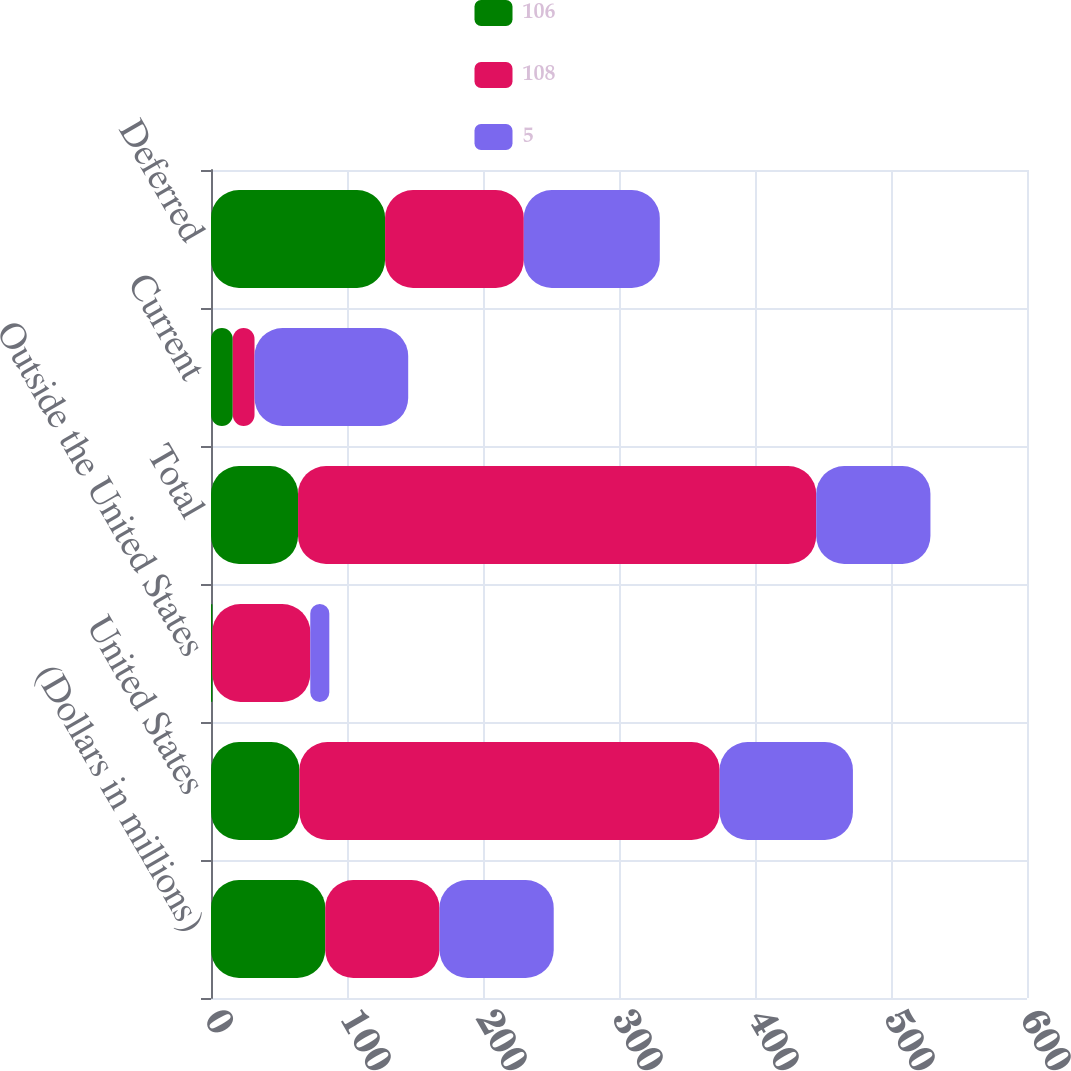Convert chart. <chart><loc_0><loc_0><loc_500><loc_500><stacked_bar_chart><ecel><fcel>(Dollars in millions)<fcel>United States<fcel>Outside the United States<fcel>Total<fcel>Current<fcel>Deferred<nl><fcel>106<fcel>84<fcel>65<fcel>1<fcel>64<fcel>16<fcel>128<nl><fcel>108<fcel>84<fcel>309<fcel>72<fcel>381<fcel>16<fcel>102<nl><fcel>5<fcel>84<fcel>98<fcel>14<fcel>84<fcel>113<fcel>100<nl></chart> 